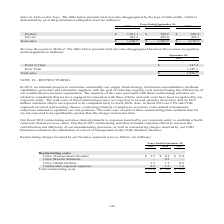According to Cubic's financial document, What did the restructuring charges incurred by the CTS and CGD segments in 2019 consist primarily of? consisting primarily of employee severance costs related to headcount reductions initiated to optimize our cost positions. The document states: "and CGD segments incurred restructuring charges, consisting primarily of employee severance costs related to headcount reductions initiated to optimiz..." Also, What did the restructuring activities in 2017 include? corporate efforts to increase the centralization and efficiency of our manufacturing processes, as well as restructuring charges incurred by our CGD businesses related to the elimination of a level of management in the CGD simulator business. The document states: "Our fiscal 2017 restructuring activities included corporate efforts to increase the centralization and efficiency of our manufacturing processes, as w..." Also, What are the years included in the table? The document contains multiple relevant values: 2019, 2018, 2017. From the document: "Years Ended September 30, 2019 2018 2017 Years Ended September 30, 2019 2018 2017 Years Ended September 30, 2019 2018 2017..." Additionally, In which year was the restructuring costs incurred by Cubic Global Defense the lowest? According to the financial document, 2017. The relevant text states: "Years Ended September 30, 2019 2018 2017..." Also, can you calculate: What is the change in the amount of total restructuring costs in 2019 from 2018? Based on the calculation: 15.4-5.0, the result is 10.4 (in millions). This is based on the information: "es 8.9 3.1 1.0 Total restructuring costs $ 15.4 $ 5.0 $ 2.3 expenses 8.9 3.1 1.0 Total restructuring costs $ 15.4 $ 5.0 $ 2.3..." The key data points involved are: 15.4, 5.0. Also, can you calculate: What is the percentage change in the amount of total restructuring costs in 2019 from 2018? To answer this question, I need to perform calculations using the financial data. The calculation is: (15.4-5.0)/5.0, which equals 208 (percentage). This is based on the information: "es 8.9 3.1 1.0 Total restructuring costs $ 15.4 $ 5.0 $ 2.3 expenses 8.9 3.1 1.0 Total restructuring costs $ 15.4 $ 5.0 $ 2.3..." The key data points involved are: 15.4, 5.0. 